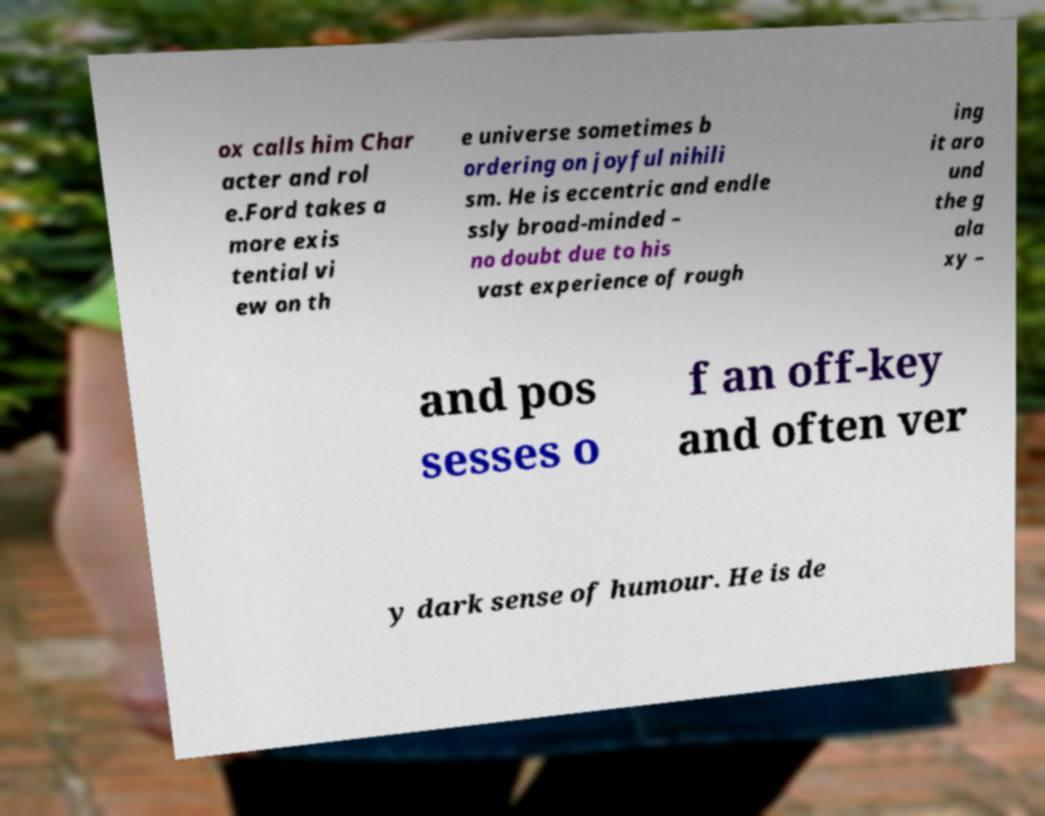Can you accurately transcribe the text from the provided image for me? ox calls him Char acter and rol e.Ford takes a more exis tential vi ew on th e universe sometimes b ordering on joyful nihili sm. He is eccentric and endle ssly broad-minded – no doubt due to his vast experience of rough ing it aro und the g ala xy – and pos sesses o f an off-key and often ver y dark sense of humour. He is de 